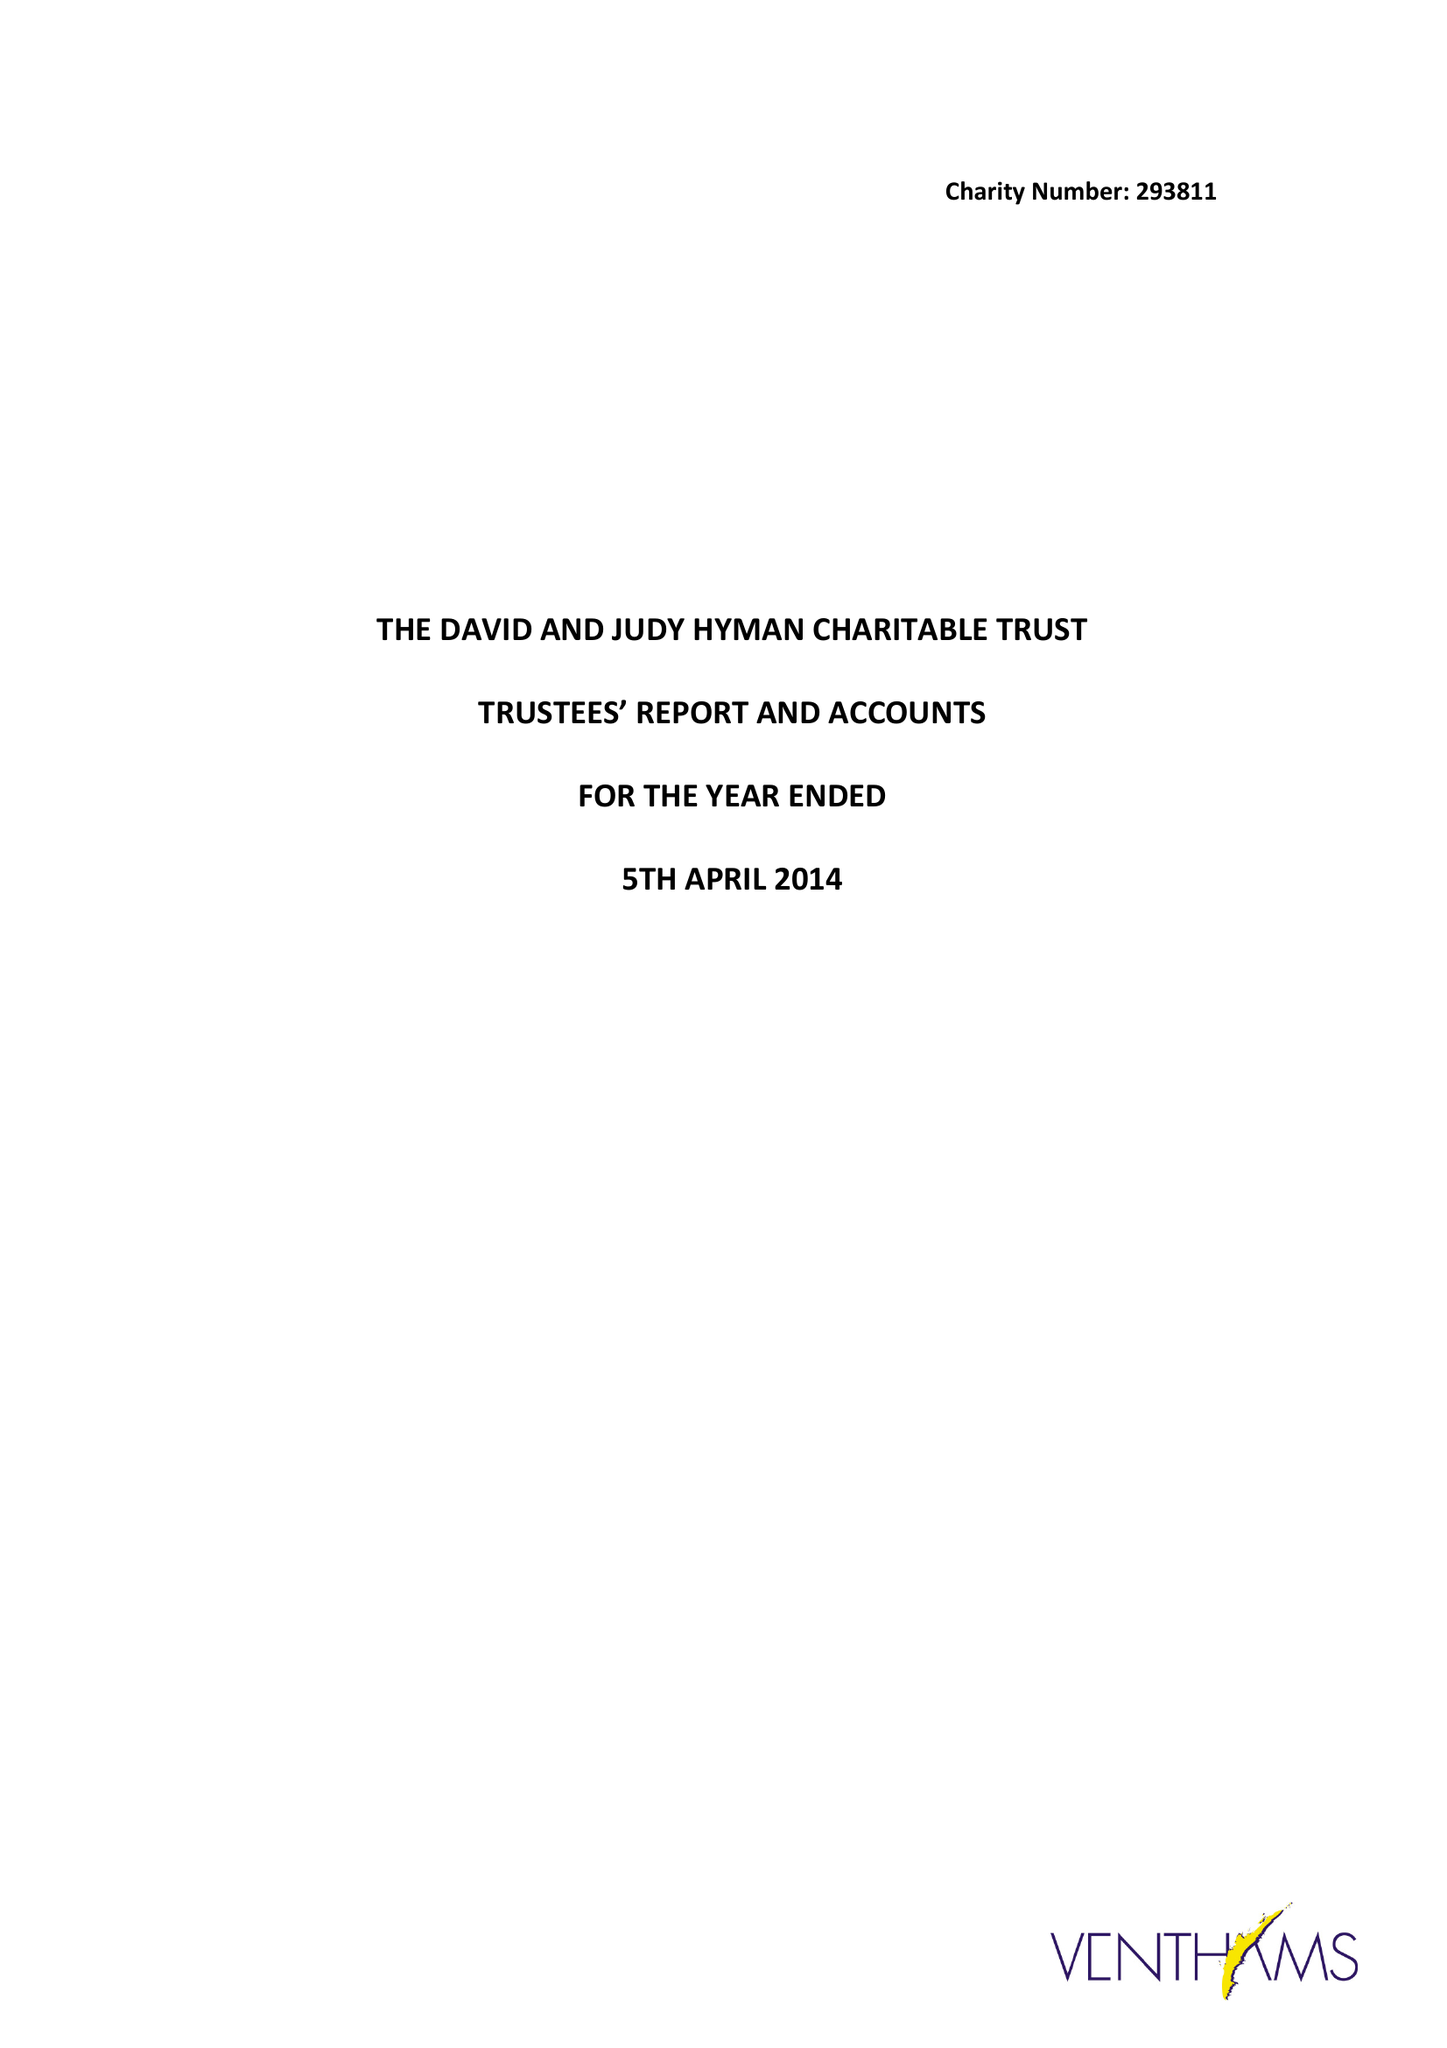What is the value for the address__postcode?
Answer the question using a single word or phrase. NW11 7BA 